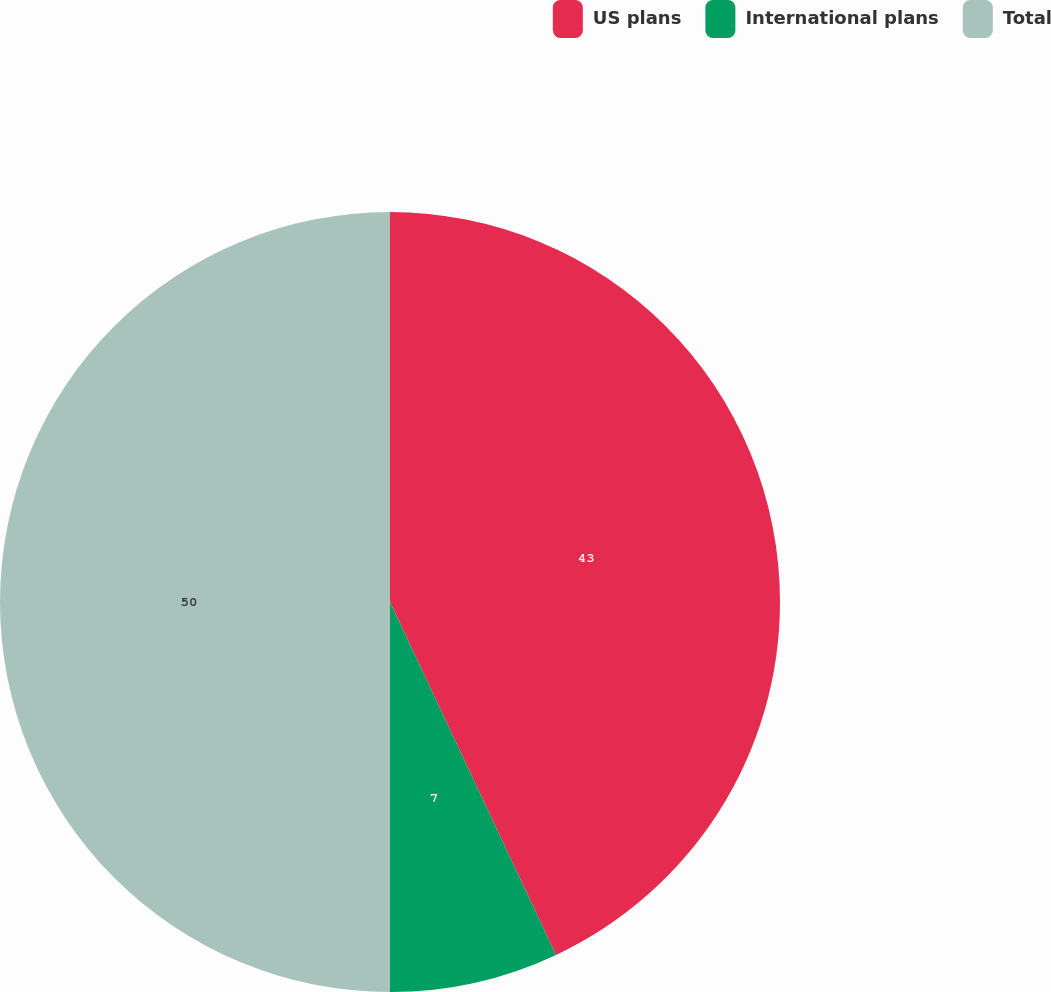Convert chart. <chart><loc_0><loc_0><loc_500><loc_500><pie_chart><fcel>US plans<fcel>International plans<fcel>Total<nl><fcel>43.0%<fcel>7.0%<fcel>50.0%<nl></chart> 